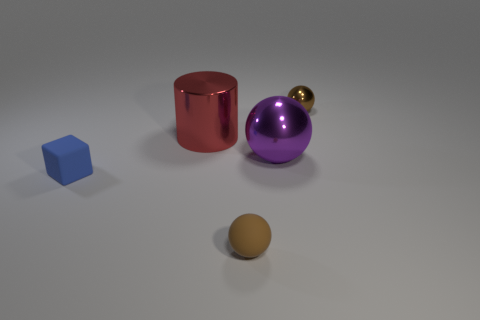What number of things are either brown metallic things or small things in front of the block?
Your answer should be compact. 2. How big is the ball that is both behind the tiny blue matte thing and in front of the large metallic cylinder?
Make the answer very short. Large. Are there more tiny blue cubes in front of the small brown matte thing than small brown balls left of the small metallic object?
Offer a very short reply. No. Do the brown rubber object and the tiny matte object left of the big red object have the same shape?
Keep it short and to the point. No. What number of other objects are there of the same shape as the tiny brown matte object?
Keep it short and to the point. 2. There is a small thing that is in front of the large red cylinder and on the right side of the red thing; what color is it?
Give a very brief answer. Brown. The rubber block has what color?
Give a very brief answer. Blue. Is the material of the cylinder the same as the block behind the brown rubber thing?
Offer a terse response. No. There is a brown object that is made of the same material as the big red cylinder; what shape is it?
Provide a succinct answer. Sphere. The matte object that is the same size as the blue rubber block is what color?
Give a very brief answer. Brown. 